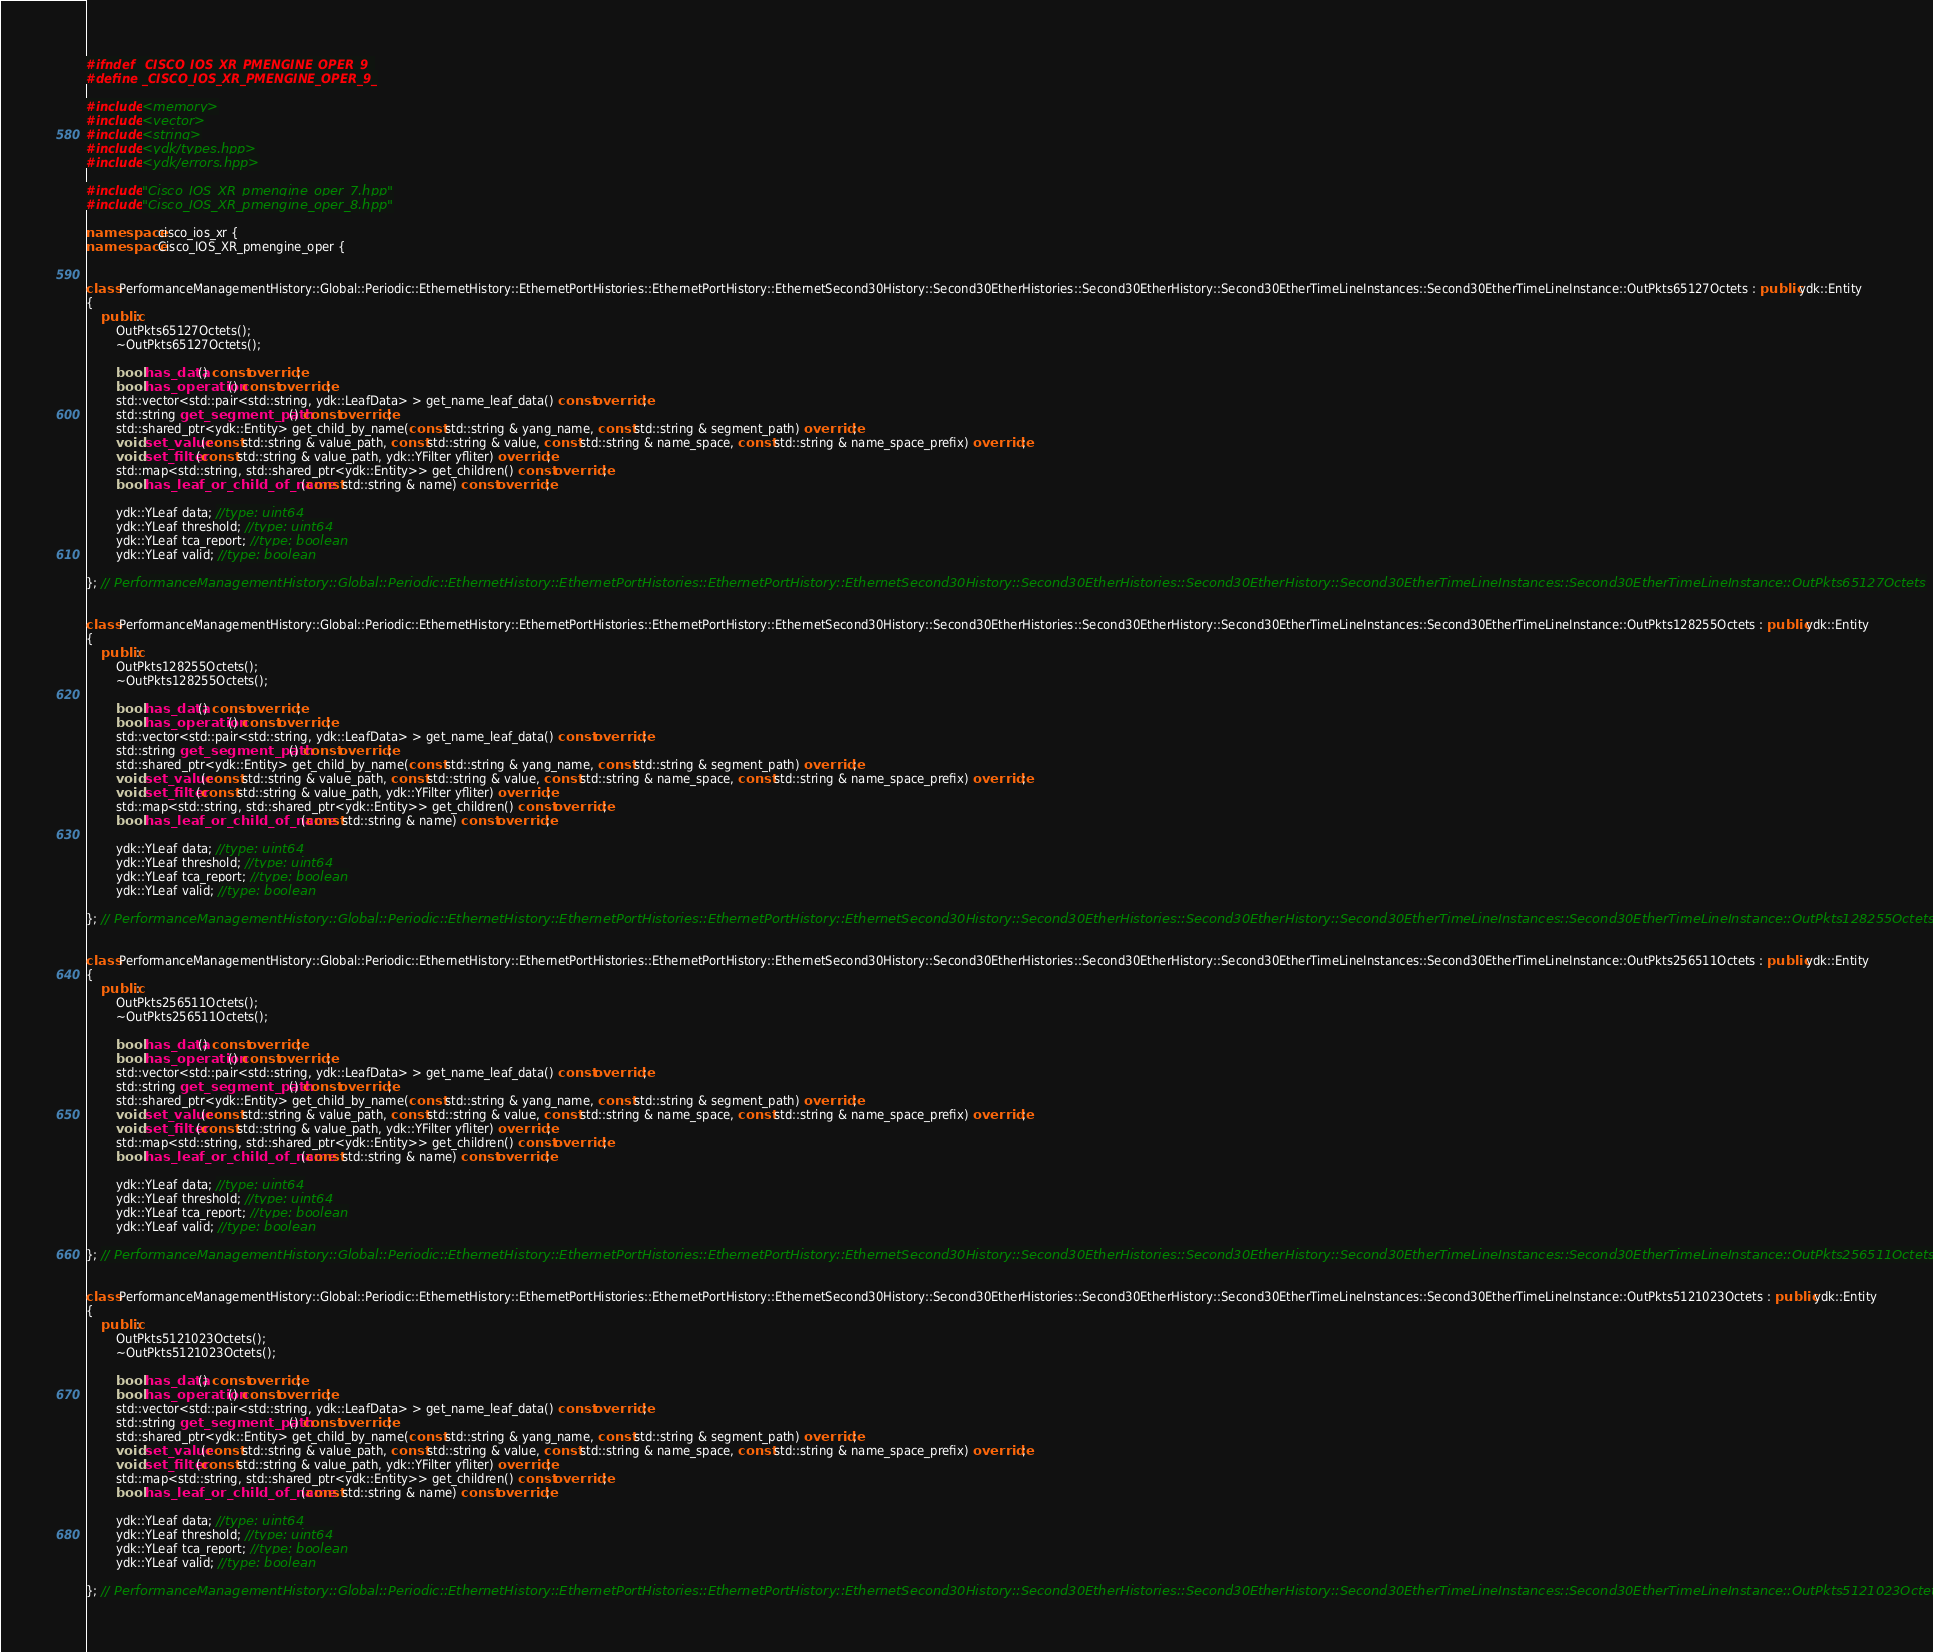Convert code to text. <code><loc_0><loc_0><loc_500><loc_500><_C++_>#ifndef _CISCO_IOS_XR_PMENGINE_OPER_9_
#define _CISCO_IOS_XR_PMENGINE_OPER_9_

#include <memory>
#include <vector>
#include <string>
#include <ydk/types.hpp>
#include <ydk/errors.hpp>

#include "Cisco_IOS_XR_pmengine_oper_7.hpp"
#include "Cisco_IOS_XR_pmengine_oper_8.hpp"

namespace cisco_ios_xr {
namespace Cisco_IOS_XR_pmengine_oper {


class PerformanceManagementHistory::Global::Periodic::EthernetHistory::EthernetPortHistories::EthernetPortHistory::EthernetSecond30History::Second30EtherHistories::Second30EtherHistory::Second30EtherTimeLineInstances::Second30EtherTimeLineInstance::OutPkts65127Octets : public ydk::Entity
{
    public:
        OutPkts65127Octets();
        ~OutPkts65127Octets();

        bool has_data() const override;
        bool has_operation() const override;
        std::vector<std::pair<std::string, ydk::LeafData> > get_name_leaf_data() const override;
        std::string get_segment_path() const override;
        std::shared_ptr<ydk::Entity> get_child_by_name(const std::string & yang_name, const std::string & segment_path) override;
        void set_value(const std::string & value_path, const std::string & value, const std::string & name_space, const std::string & name_space_prefix) override;
        void set_filter(const std::string & value_path, ydk::YFilter yfliter) override;
        std::map<std::string, std::shared_ptr<ydk::Entity>> get_children() const override;
        bool has_leaf_or_child_of_name(const std::string & name) const override;

        ydk::YLeaf data; //type: uint64
        ydk::YLeaf threshold; //type: uint64
        ydk::YLeaf tca_report; //type: boolean
        ydk::YLeaf valid; //type: boolean

}; // PerformanceManagementHistory::Global::Periodic::EthernetHistory::EthernetPortHistories::EthernetPortHistory::EthernetSecond30History::Second30EtherHistories::Second30EtherHistory::Second30EtherTimeLineInstances::Second30EtherTimeLineInstance::OutPkts65127Octets


class PerformanceManagementHistory::Global::Periodic::EthernetHistory::EthernetPortHistories::EthernetPortHistory::EthernetSecond30History::Second30EtherHistories::Second30EtherHistory::Second30EtherTimeLineInstances::Second30EtherTimeLineInstance::OutPkts128255Octets : public ydk::Entity
{
    public:
        OutPkts128255Octets();
        ~OutPkts128255Octets();

        bool has_data() const override;
        bool has_operation() const override;
        std::vector<std::pair<std::string, ydk::LeafData> > get_name_leaf_data() const override;
        std::string get_segment_path() const override;
        std::shared_ptr<ydk::Entity> get_child_by_name(const std::string & yang_name, const std::string & segment_path) override;
        void set_value(const std::string & value_path, const std::string & value, const std::string & name_space, const std::string & name_space_prefix) override;
        void set_filter(const std::string & value_path, ydk::YFilter yfliter) override;
        std::map<std::string, std::shared_ptr<ydk::Entity>> get_children() const override;
        bool has_leaf_or_child_of_name(const std::string & name) const override;

        ydk::YLeaf data; //type: uint64
        ydk::YLeaf threshold; //type: uint64
        ydk::YLeaf tca_report; //type: boolean
        ydk::YLeaf valid; //type: boolean

}; // PerformanceManagementHistory::Global::Periodic::EthernetHistory::EthernetPortHistories::EthernetPortHistory::EthernetSecond30History::Second30EtherHistories::Second30EtherHistory::Second30EtherTimeLineInstances::Second30EtherTimeLineInstance::OutPkts128255Octets


class PerformanceManagementHistory::Global::Periodic::EthernetHistory::EthernetPortHistories::EthernetPortHistory::EthernetSecond30History::Second30EtherHistories::Second30EtherHistory::Second30EtherTimeLineInstances::Second30EtherTimeLineInstance::OutPkts256511Octets : public ydk::Entity
{
    public:
        OutPkts256511Octets();
        ~OutPkts256511Octets();

        bool has_data() const override;
        bool has_operation() const override;
        std::vector<std::pair<std::string, ydk::LeafData> > get_name_leaf_data() const override;
        std::string get_segment_path() const override;
        std::shared_ptr<ydk::Entity> get_child_by_name(const std::string & yang_name, const std::string & segment_path) override;
        void set_value(const std::string & value_path, const std::string & value, const std::string & name_space, const std::string & name_space_prefix) override;
        void set_filter(const std::string & value_path, ydk::YFilter yfliter) override;
        std::map<std::string, std::shared_ptr<ydk::Entity>> get_children() const override;
        bool has_leaf_or_child_of_name(const std::string & name) const override;

        ydk::YLeaf data; //type: uint64
        ydk::YLeaf threshold; //type: uint64
        ydk::YLeaf tca_report; //type: boolean
        ydk::YLeaf valid; //type: boolean

}; // PerformanceManagementHistory::Global::Periodic::EthernetHistory::EthernetPortHistories::EthernetPortHistory::EthernetSecond30History::Second30EtherHistories::Second30EtherHistory::Second30EtherTimeLineInstances::Second30EtherTimeLineInstance::OutPkts256511Octets


class PerformanceManagementHistory::Global::Periodic::EthernetHistory::EthernetPortHistories::EthernetPortHistory::EthernetSecond30History::Second30EtherHistories::Second30EtherHistory::Second30EtherTimeLineInstances::Second30EtherTimeLineInstance::OutPkts5121023Octets : public ydk::Entity
{
    public:
        OutPkts5121023Octets();
        ~OutPkts5121023Octets();

        bool has_data() const override;
        bool has_operation() const override;
        std::vector<std::pair<std::string, ydk::LeafData> > get_name_leaf_data() const override;
        std::string get_segment_path() const override;
        std::shared_ptr<ydk::Entity> get_child_by_name(const std::string & yang_name, const std::string & segment_path) override;
        void set_value(const std::string & value_path, const std::string & value, const std::string & name_space, const std::string & name_space_prefix) override;
        void set_filter(const std::string & value_path, ydk::YFilter yfliter) override;
        std::map<std::string, std::shared_ptr<ydk::Entity>> get_children() const override;
        bool has_leaf_or_child_of_name(const std::string & name) const override;

        ydk::YLeaf data; //type: uint64
        ydk::YLeaf threshold; //type: uint64
        ydk::YLeaf tca_report; //type: boolean
        ydk::YLeaf valid; //type: boolean

}; // PerformanceManagementHistory::Global::Periodic::EthernetHistory::EthernetPortHistories::EthernetPortHistory::EthernetSecond30History::Second30EtherHistories::Second30EtherHistory::Second30EtherTimeLineInstances::Second30EtherTimeLineInstance::OutPkts5121023Octets

</code> 